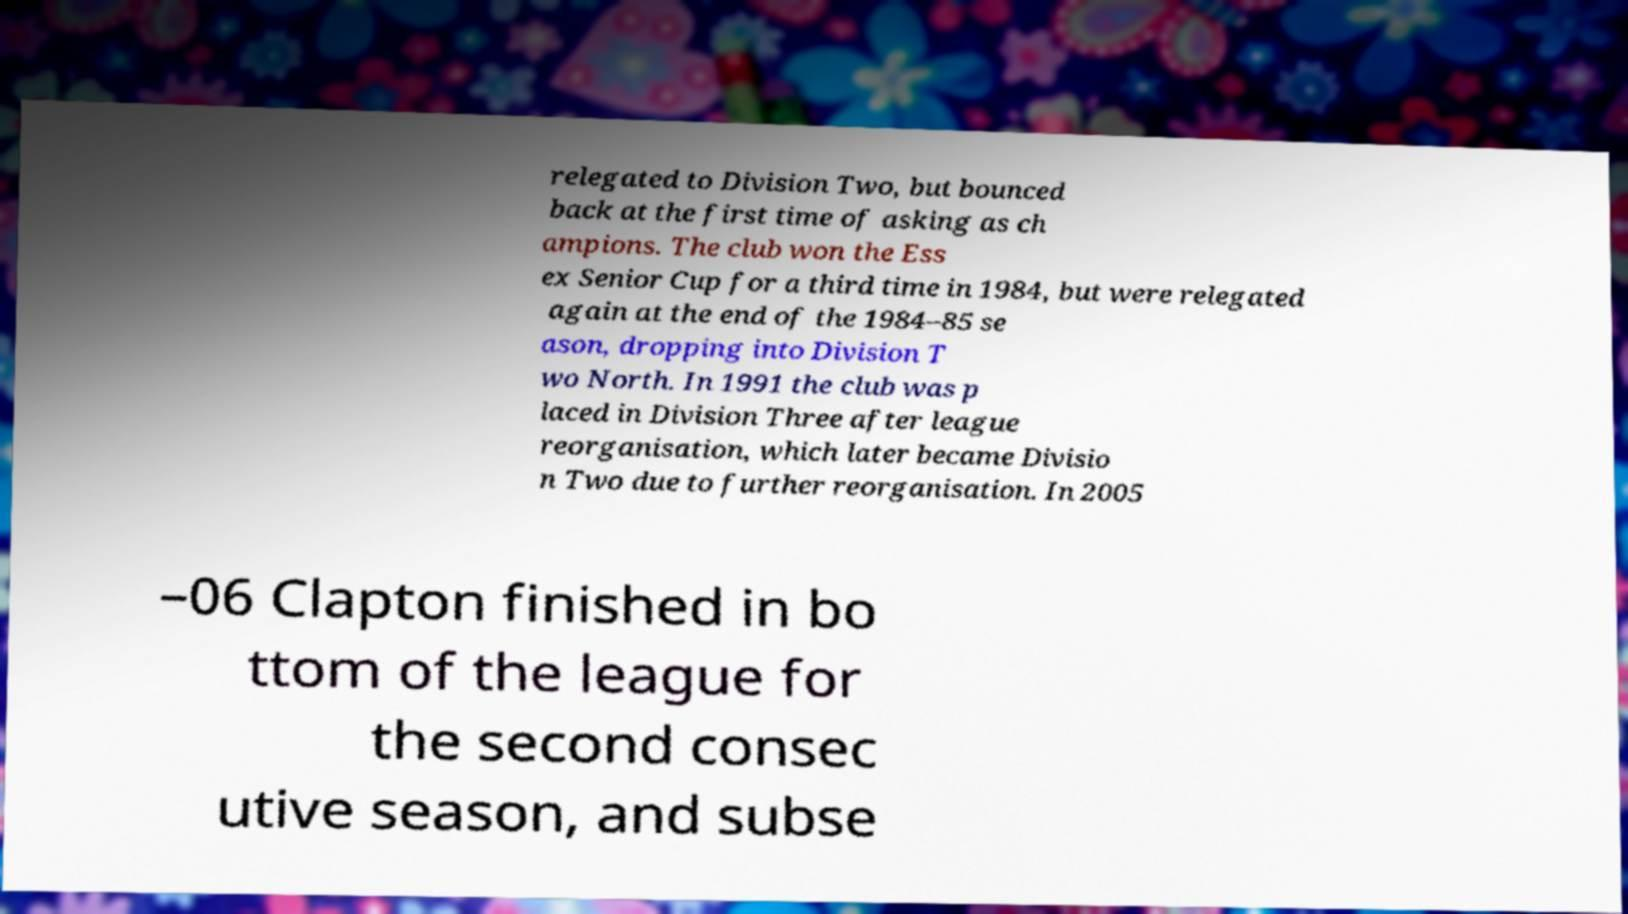Could you assist in decoding the text presented in this image and type it out clearly? relegated to Division Two, but bounced back at the first time of asking as ch ampions. The club won the Ess ex Senior Cup for a third time in 1984, but were relegated again at the end of the 1984–85 se ason, dropping into Division T wo North. In 1991 the club was p laced in Division Three after league reorganisation, which later became Divisio n Two due to further reorganisation. In 2005 –06 Clapton finished in bo ttom of the league for the second consec utive season, and subse 